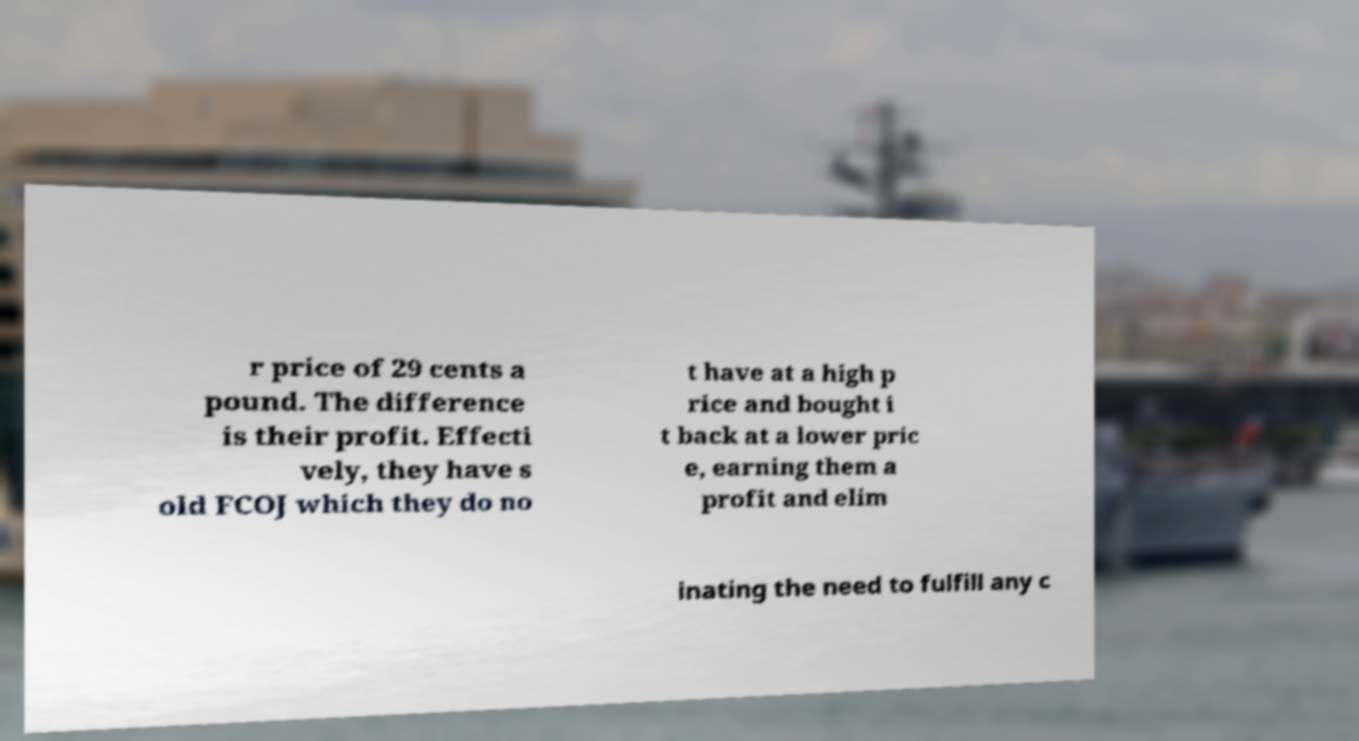Could you assist in decoding the text presented in this image and type it out clearly? r price of 29 cents a pound. The difference is their profit. Effecti vely, they have s old FCOJ which they do no t have at a high p rice and bought i t back at a lower pric e, earning them a profit and elim inating the need to fulfill any c 